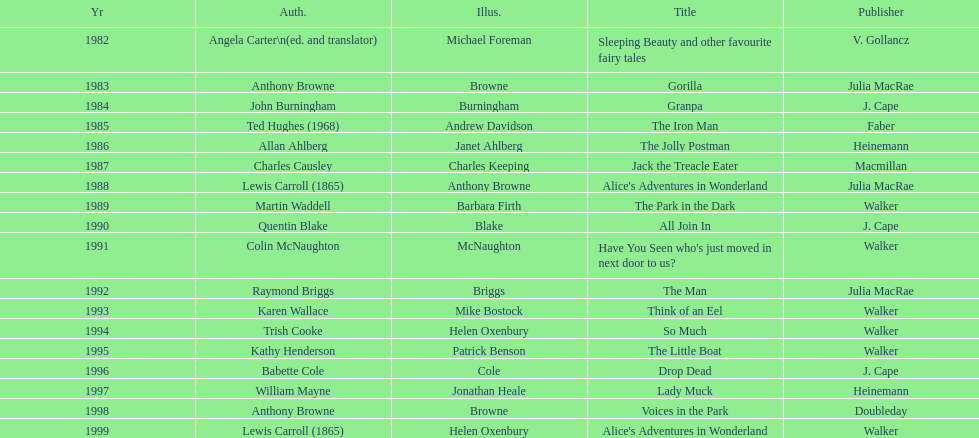Which illustrator was responsible for the last award winner? Helen Oxenbury. 